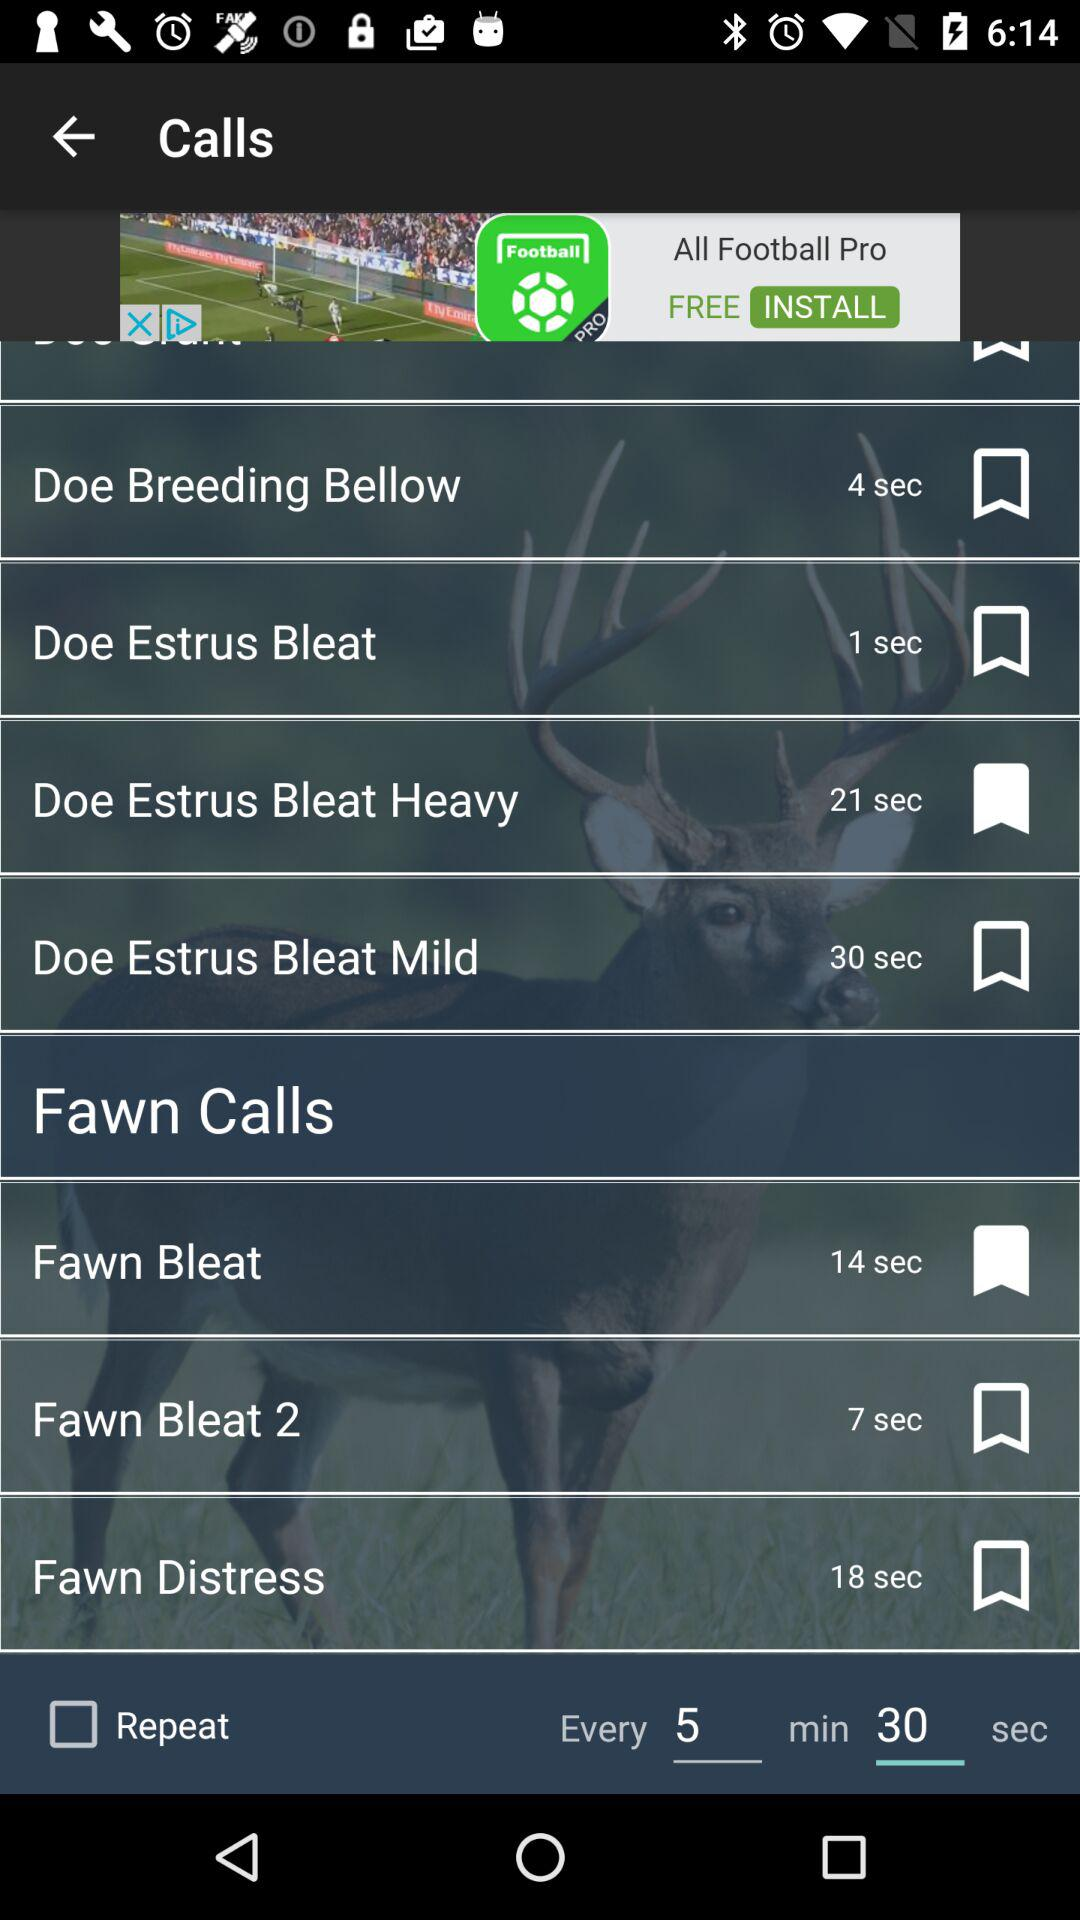Which call has a duration of 14 seconds? The call "Fawn Bleat" has a duration of 14 seconds. 